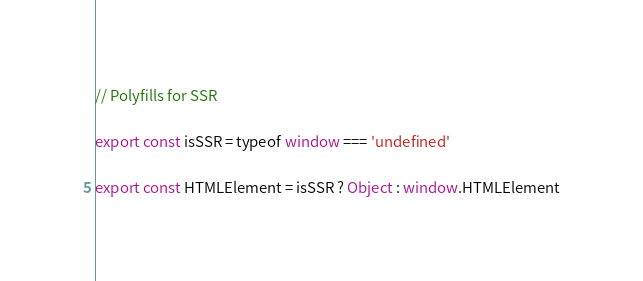<code> <loc_0><loc_0><loc_500><loc_500><_JavaScript_>// Polyfills for SSR

export const isSSR = typeof window === 'undefined'

export const HTMLElement = isSSR ? Object : window.HTMLElement
</code> 